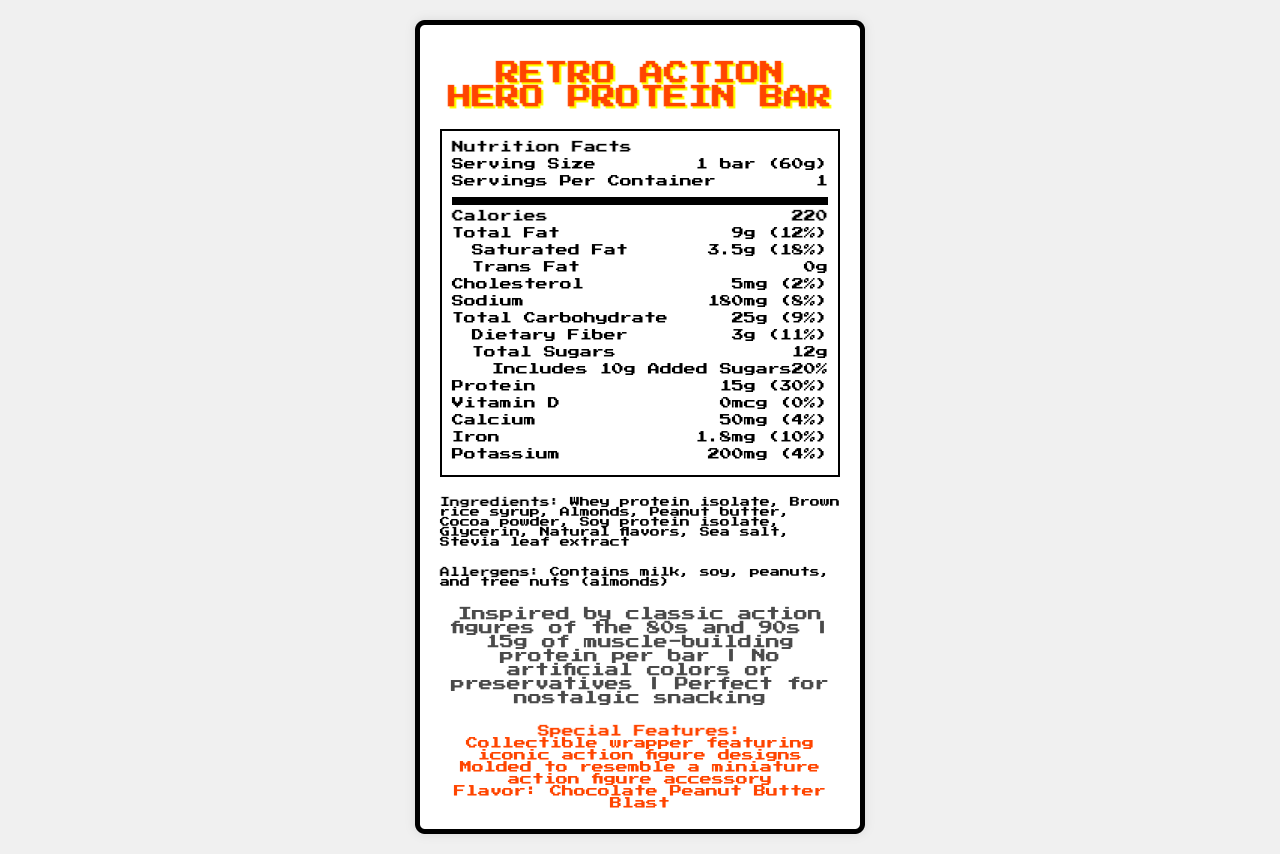what is the serving size of the Retro Action Hero Protein Bar? The serving size is clearly mentioned in the nutrition facts section as "1 bar (60g)".
Answer: 1 bar (60g) how many calories are in one serving of the Retro Action Hero Protein Bar? The calories per serving are listed as 220 in the nutrition facts section.
Answer: 220 what is the total fat content per serving? The total fat content per serving is listed as 9g.
Answer: 9g what allergens are mentioned on the label? The allergens are listed below the ingredients section and include milk, soy, peanuts, and tree nuts (almonds).
Answer: "Contains milk, soy, peanuts, and tree nuts (almonds)" how much protein does this bar provide? The protein content per serving is listed as 15g.
Answer: 15g what is the percentage daily value of saturated fat per serving? The percentage daily value for saturated fat is given as 18%.
Answer: 18% which of the following ingredients is not in the Retro Action Hero Protein Bar? A. Whey protein isolate B. Honey C. Cocoa powder D. Sea salt The ingredients list includes whey protein isolate, cocoa powder, and sea salt, but not honey.
Answer: B what special features does the packaging of the Retro Action Hero Protein Bar have? The special features section mentions that the packaging has a collectible wrapper featuring iconic action figure designs.
Answer: Collectible wrapper featuring iconic action figure designs is there any vitamin D in this protein bar? The nutrition facts section shows that the vitamin D content is 0mcg, which means there is no vitamin D in the bar.
Answer: No what is the flavor of the Retro Action Hero Protein Bar? The special features mention that the flavor is Chocolate Peanut Butter Blast.
Answer: Chocolate Peanut Butter Blast how much added sugar is in this protein bar? The nutrition facts section indicates that the protein bar includes 10g of added sugars.
Answer: 10g does this protein bar include any artificial colors or preservatives? One of the marketing claims states that there are no artificial colors or preservatives in the bar.
Answer: No describe the main idea of the document The document essentially outlines all relevant details about the Retro Action Hero Protein Bar, focusing on its appeal to nostalgia, its nutritional benefits, and its unique collectible packaging.
Answer: The document provides detailed nutritional information and special features for the Retro Action Hero Protein Bar, which is designed to appeal to adult fans of classic action figures. It highlights its nutritional content, ingredients, allergens, and marketing claims, including a nostalgic theme and unique packaging. what is the potassium content per serving? According to the nutrition facts section, the potassium content per serving is 200mg.
Answer: 200mg how many servings are in each container? The servings per container are listed as 1 in the nutrition facts section.
Answer: 1 what is the total carbohydrate content per serving? The nutrition facts section lists the total carbohydrate content as 25g.
Answer: 25g what marketing claims are highlighted on the document? The marketing claims listed in the document include inspiration from classic action figures, high protein content, no artificial colors or preservatives, and being perfect for nostalgic snacking.
Answer: "Inspired by classic action figures of the 80s and 90s", "15g of muscle-building protein per bar", "No artificial colors or preservatives", "Perfect for nostalgic snacking" what company produces the Retro Action Hero Protein Bar? The document does not provide any information about the company that produces the Retro Action Hero Protein Bar.
Answer: I don't know how much sodium does the protein bar contain? A. 100mg B. 150mg C. 180mg D. 200mg The nutrition facts section specifically lists 180mg as the sodium content per serving.
Answer: C what is the percentage of daily value for iron provided by one serving? The nutrition facts section lists the iron content as providing 10% of the daily value.
Answer: 10% 